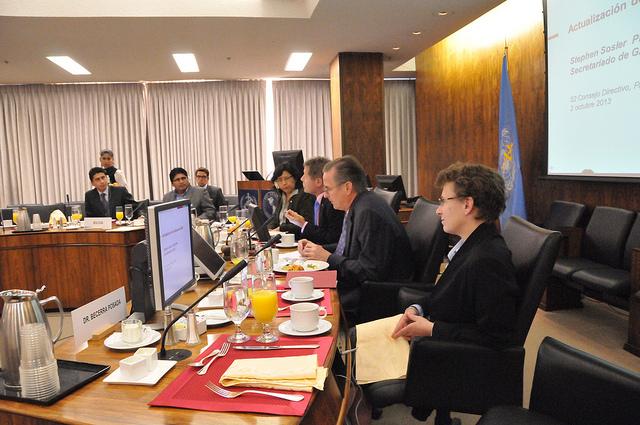How many people are in this picture?
Concise answer only. 8. What color are the placemats?
Answer briefly. Red. Are the people going to eat?
Give a very brief answer. Yes. What is the woman in the foreground holding in her hand?
Give a very brief answer. Napkin. What color are the chairs?
Answer briefly. Black. 